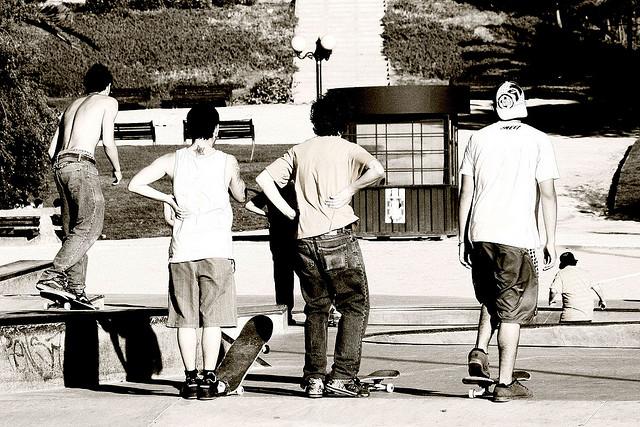What is under their feet?
Keep it brief. Skateboards. Are they in a skateboard park?
Quick response, please. Yes. How many people are there?
Give a very brief answer. 5. How many people are shirtless?
Concise answer only. 1. 